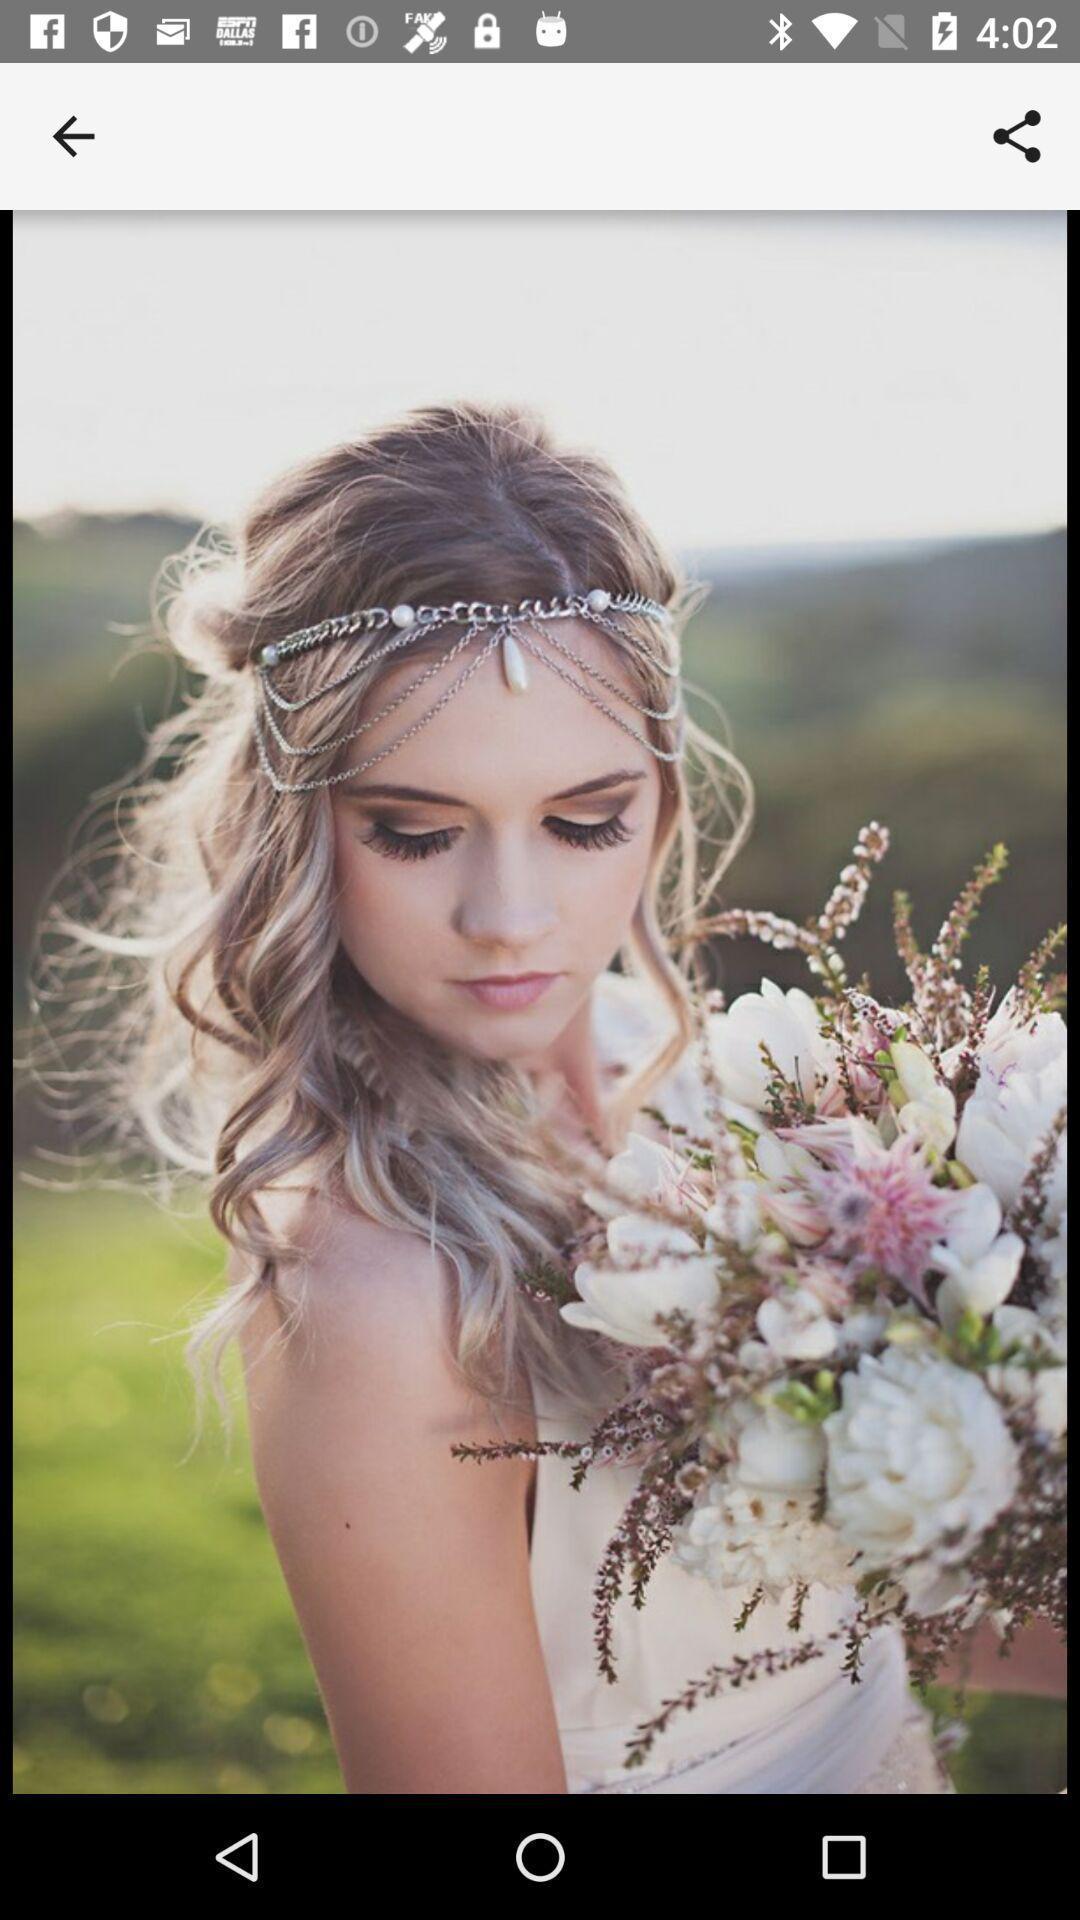Tell me what you see in this picture. Page that displaying a women image. 